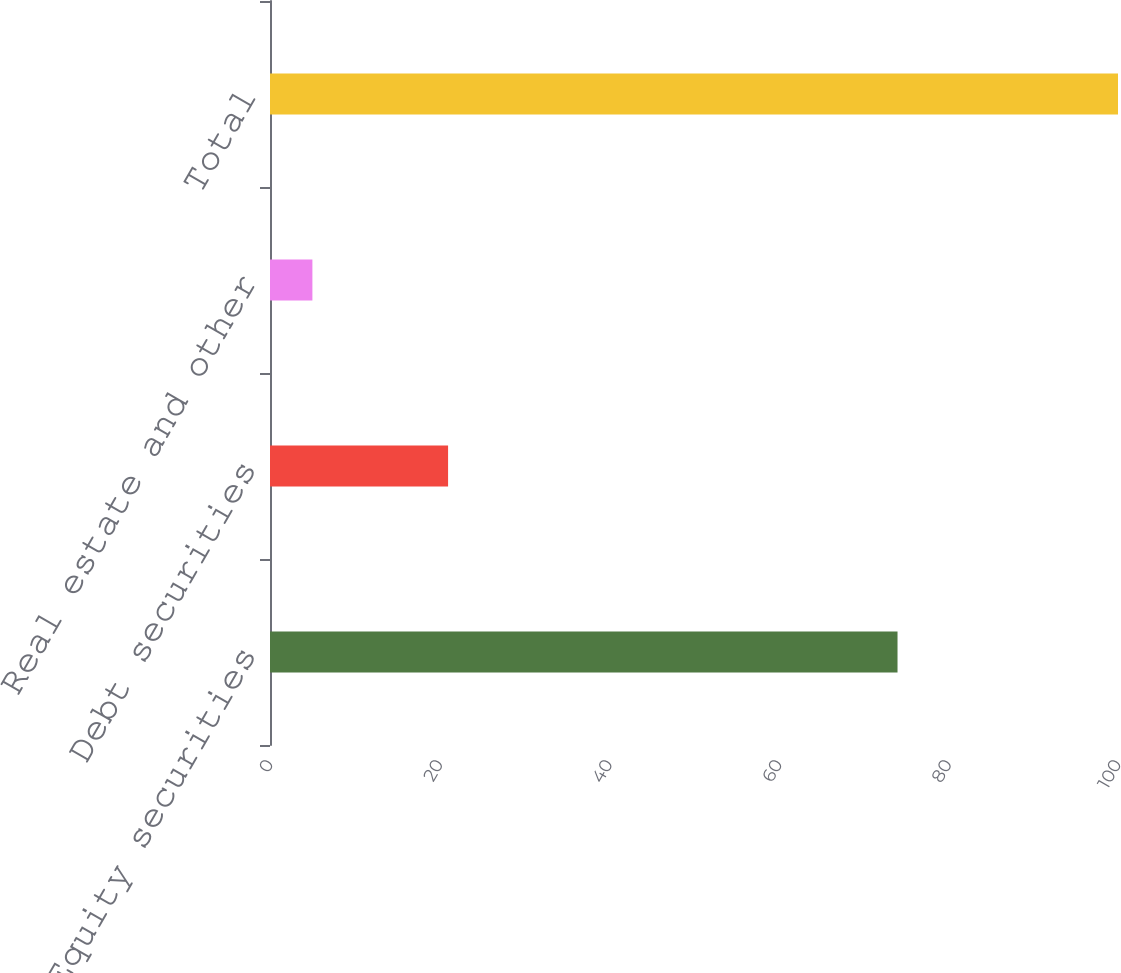Convert chart. <chart><loc_0><loc_0><loc_500><loc_500><bar_chart><fcel>Equity securities<fcel>Debt securities<fcel>Real estate and other<fcel>Total<nl><fcel>74<fcel>21<fcel>5<fcel>100<nl></chart> 